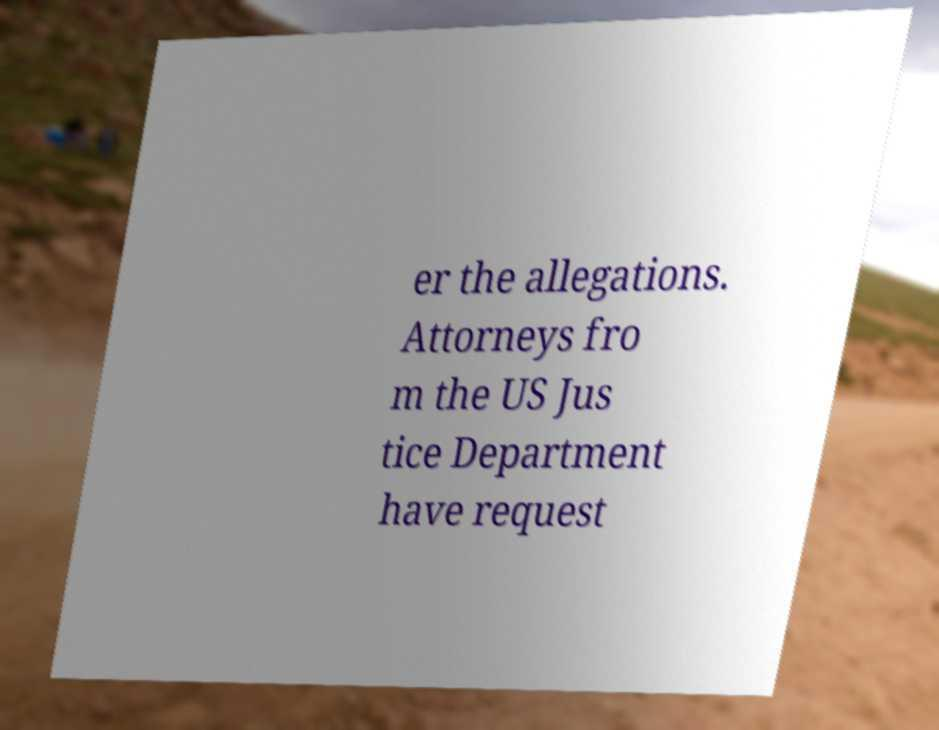Can you accurately transcribe the text from the provided image for me? er the allegations. Attorneys fro m the US Jus tice Department have request 